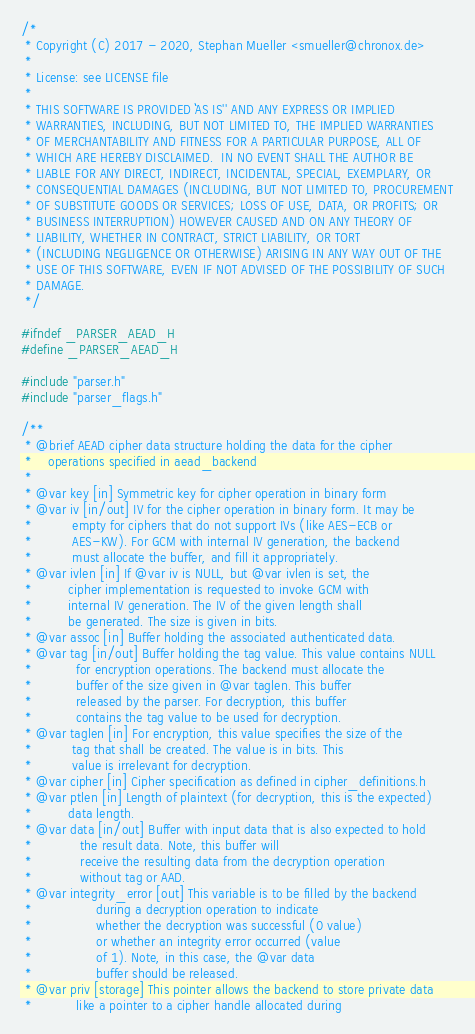<code> <loc_0><loc_0><loc_500><loc_500><_C_>/*
 * Copyright (C) 2017 - 2020, Stephan Mueller <smueller@chronox.de>
 *
 * License: see LICENSE file
 *
 * THIS SOFTWARE IS PROVIDED ``AS IS'' AND ANY EXPRESS OR IMPLIED
 * WARRANTIES, INCLUDING, BUT NOT LIMITED TO, THE IMPLIED WARRANTIES
 * OF MERCHANTABILITY AND FITNESS FOR A PARTICULAR PURPOSE, ALL OF
 * WHICH ARE HEREBY DISCLAIMED.  IN NO EVENT SHALL THE AUTHOR BE
 * LIABLE FOR ANY DIRECT, INDIRECT, INCIDENTAL, SPECIAL, EXEMPLARY, OR
 * CONSEQUENTIAL DAMAGES (INCLUDING, BUT NOT LIMITED TO, PROCUREMENT
 * OF SUBSTITUTE GOODS OR SERVICES; LOSS OF USE, DATA, OR PROFITS; OR
 * BUSINESS INTERRUPTION) HOWEVER CAUSED AND ON ANY THEORY OF
 * LIABILITY, WHETHER IN CONTRACT, STRICT LIABILITY, OR TORT
 * (INCLUDING NEGLIGENCE OR OTHERWISE) ARISING IN ANY WAY OUT OF THE
 * USE OF THIS SOFTWARE, EVEN IF NOT ADVISED OF THE POSSIBILITY OF SUCH
 * DAMAGE.
 */

#ifndef _PARSER_AEAD_H
#define _PARSER_AEAD_H

#include "parser.h"
#include "parser_flags.h"

/**
 * @brief AEAD cipher data structure holding the data for the cipher
 *	  operations specified in aead_backend
 *
 * @var key [in] Symmetric key for cipher operation in binary form
 * @var iv [in/out] IV for the cipher operation in binary form. It may be
 *		    empty for ciphers that do not support IVs (like AES-ECB or
 *		    AES-KW). For GCM with internal IV generation, the backend
 *		    must allocate the buffer, and fill it appropriately.
 * @var ivlen [in] If @var iv is NULL, but @var ivlen is set, the
 *		   cipher implementation is requested to invoke GCM with
 *		   internal IV generation. The IV of the given length shall
 *		   be generated. The size is given in bits.
 * @var assoc [in] Buffer holding the associated authenticated data.
 * @var tag [in/out] Buffer holding the tag value. This value contains NULL
 *		     for encryption operations. The backend must allocate the
 *		     buffer of the size given in @var taglen. This buffer
 *		     released by the parser. For decryption, this buffer
 *		     contains the tag value to be used for decryption.
 * @var taglen [in] For encryption, this value specifies the size of the
 *		    tag that shall be created. The value is in bits. This
 *		    value is irrelevant for decryption.
 * @var cipher [in] Cipher specification as defined in cipher_definitions.h
 * @var ptlen [in] Length of plaintext (for decryption, this is the expected)
 *		   data length.
 * @var data [in/out] Buffer with input data that is also expected to hold
 *		      the result data. Note, this buffer will
 *		      receive the resulting data from the decryption operation
 *		      without tag or AAD.
 * @var integrity_error [out] This variable is to be filled by the backend
 *			      during a decryption operation to indicate
 *			      whether the decryption was successful (0 value)
 *			      or whether an integrity error occurred (value
 *			      of 1). Note, in this case, the @var data
 *			      buffer should be released.
 * @var priv [storage] This pointer allows the backend to store private data
 *			 like a pointer to a cipher handle allocated during</code> 